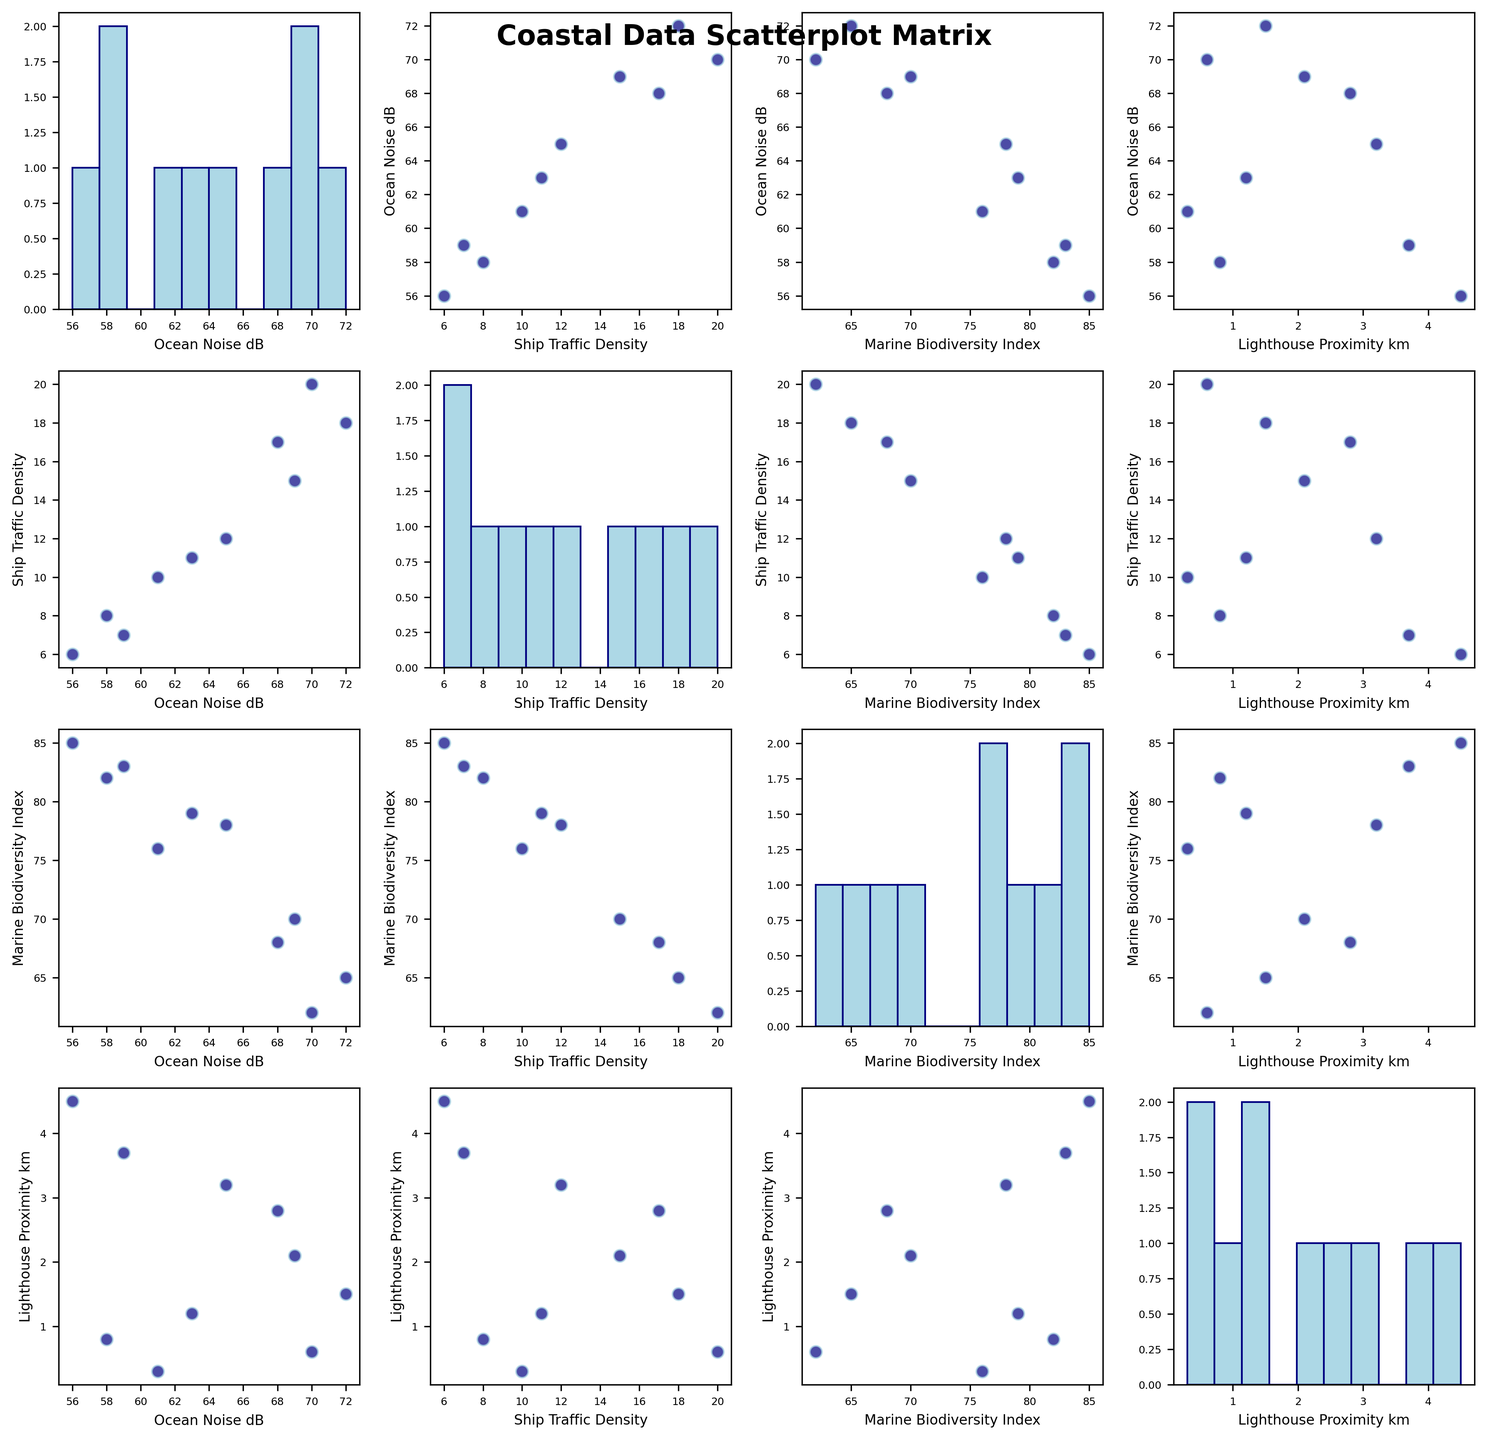What is the title of the figure? The title of the figure is usually displayed at the top of the chart. For this scatterplot matrix, the title "Coastal Data Scatterplot Matrix" should be found prominently on the figure.
Answer: Coastal Data Scatterplot Matrix How many scatter plots are displayed in the figure? The scatterplot matrix is created by plotting each variable against every other variable, excluding diagonal elements. With 4 variables, there are 4x4 total plots, excluding 4 diagonal histograms, resulting in 12 scatter plots.
Answer: 12 Which variable shows the highest range when looking at the histograms on the diagonal? To determine the highest range, look at the spread of each histogram on the diagonal. "Ship Traffic Density" varies from around 6 to 20, while other variables have narrower ranges. Thus, Ship Traffic Density has the highest range.
Answer: Ship Traffic Density Is there a visible trend between Ocean Noise and Ship Traffic Density? By examining the scatter plot between "Ocean Noise dB" and "Ship Traffic Density," one can identify if there is a pattern. Ship Traffic Density and Ocean Noise seem to have a positive correlation.
Answer: Yes What is the relationship between Marine Biodiversity Index and Lighthouse Proximity? Examine the scatter plot between "Marine Biodiversity Index" and "Lighthouse Proximity." The scatter points suggest no clear linear relationship between these two variables.
Answer: No clear relationship Which coastal location has the highest Marine Biodiversity Index? By checking the maximum bin value in the histogram of "Marine Biodiversity Index," it reaches 85. Looking up this value in the data, Point Reyes has the highest Marine Biodiversity Index.
Answer: Point Reyes Is there a negative correlation between Ocean Noise and Marine Biodiversity Index? In the scatter plot between "Ocean Noise dB" and "Marine Biodiversity Index," the points generally slope downwards from left to right, indicating a negative correlation.
Answer: Yes How does Lighthouse Proximity correlate with Ship Traffic Density? Reviewing the scatter plot between "Lighthouse Proximity km" and "Ship Traffic Density," the points do not display any evident linear relationship, suggesting weak or no clear correlation.
Answer: Weak or no correlation Comparing Ocean Noise and Marine Biodiversity Index scatter plots, which variable pairs have the strongest negative relationships? After analyzing the scatter plots involving "Marine Biodiversity Index," the strongest negative relationship appears to be between "Ocean Noise" and "Marine Biodiversity Index," as the slope is steeper there than in other plots.
Answer: Ocean Noise and Marine Biodiversity Index What is the average Ship Traffic Density across all coastal areas? By summing all the entries in the "Ship Traffic Density" column and dividing by the number of coastal areas (10), we get (12 + 18 + 8 + 10 + 15 + 6 + 20 + 11 + 17 + 7) / 10 = 124 / 10.
Answer: 12.4 